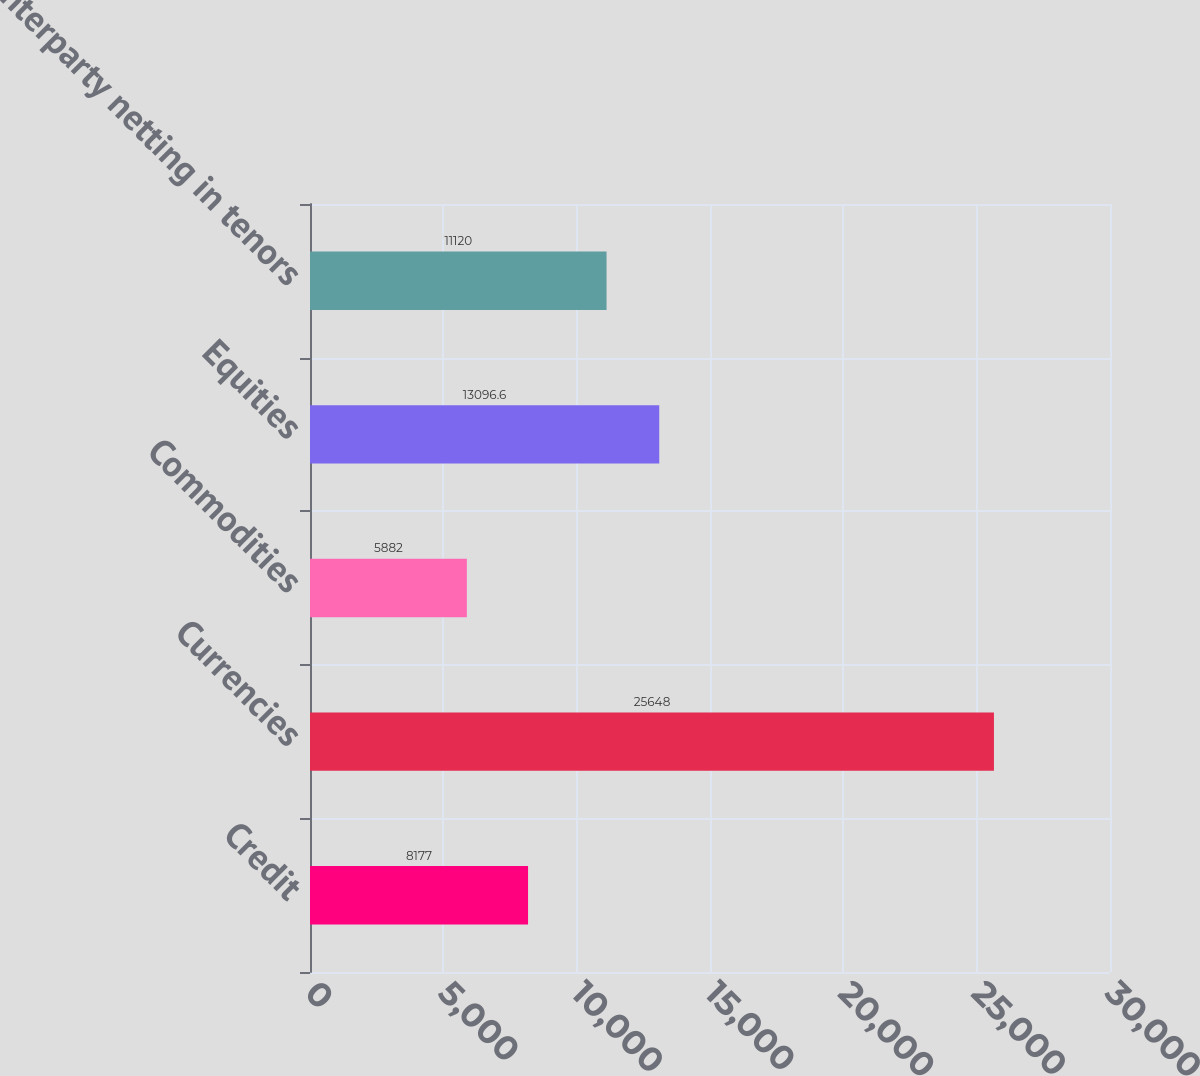Convert chart to OTSL. <chart><loc_0><loc_0><loc_500><loc_500><bar_chart><fcel>Credit<fcel>Currencies<fcel>Commodities<fcel>Equities<fcel>Counterparty netting in tenors<nl><fcel>8177<fcel>25648<fcel>5882<fcel>13096.6<fcel>11120<nl></chart> 